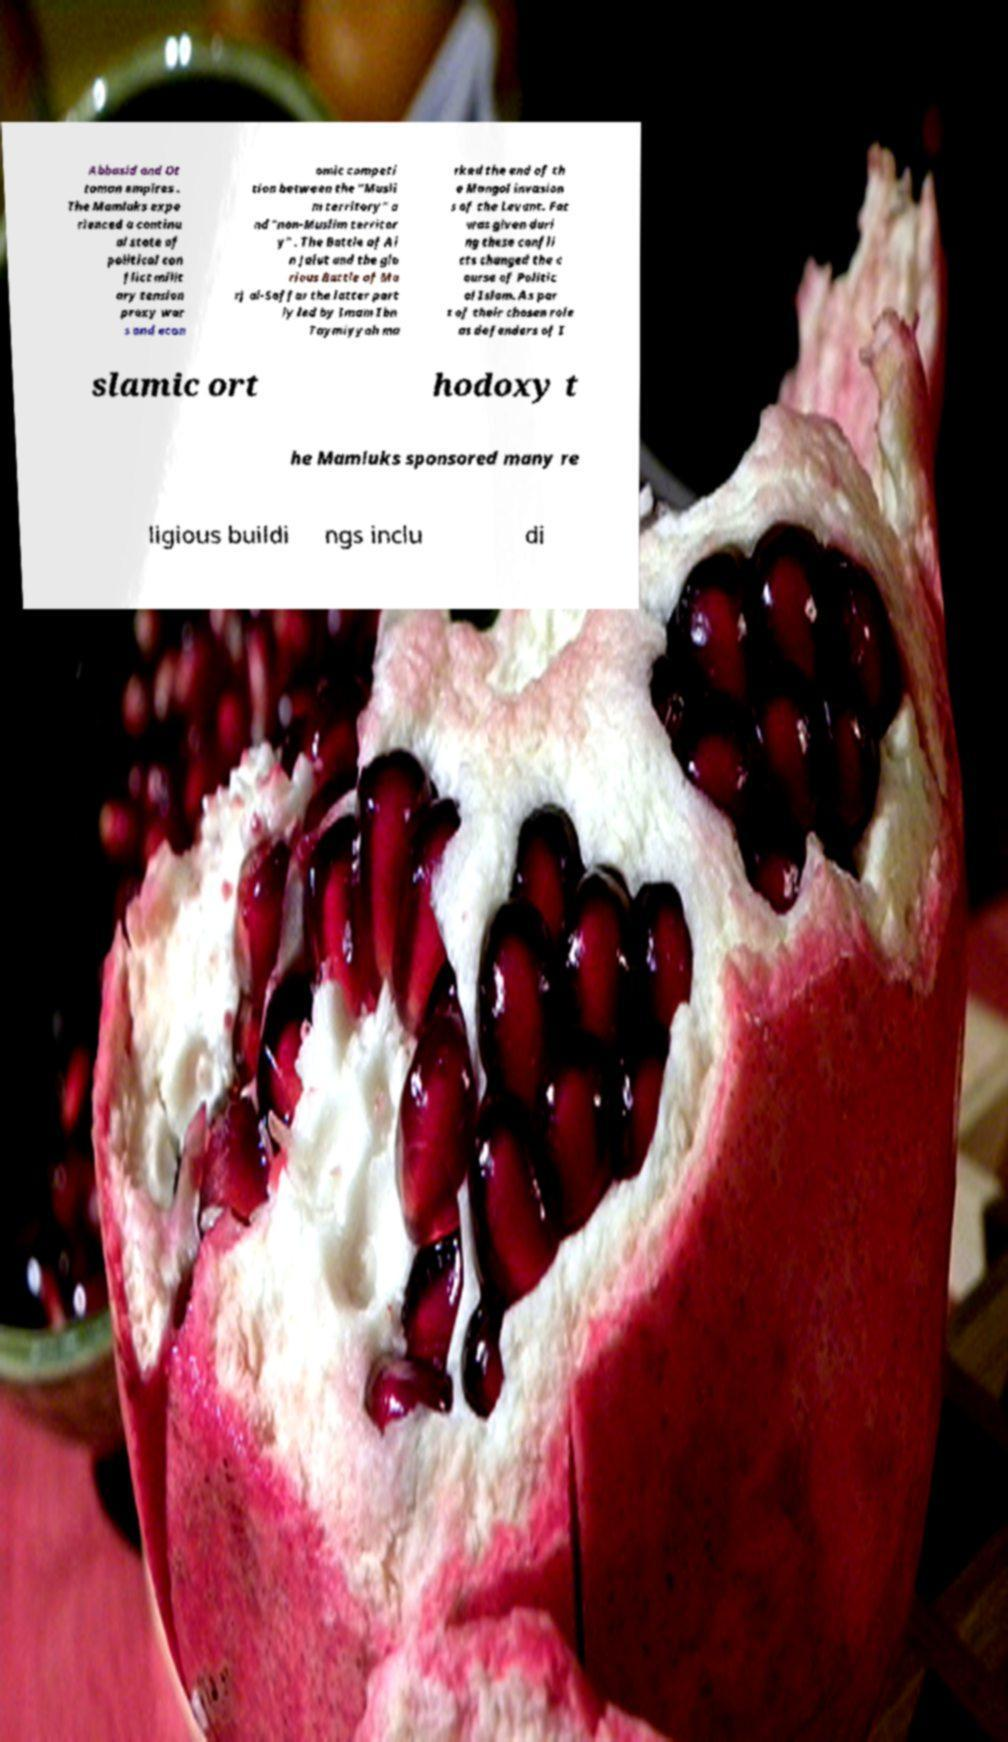Could you extract and type out the text from this image? Abbasid and Ot toman empires . The Mamluks expe rienced a continu al state of political con flict milit ary tension proxy war s and econ omic competi tion between the "Musli m territory" a nd "non-Muslim territor y" . The Battle of Ai n Jalut and the glo rious Battle of Ma rj al-Saffar the latter part ly led by Imam Ibn Taymiyyah ma rked the end of th e Mongol invasion s of the Levant. Fat was given duri ng these confli cts changed the c ourse of Politic al Islam. As par t of their chosen role as defenders of I slamic ort hodoxy t he Mamluks sponsored many re ligious buildi ngs inclu di 